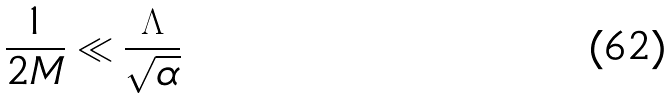<formula> <loc_0><loc_0><loc_500><loc_500>\frac { 1 } { 2 M } \ll \frac { \Lambda } { \sqrt { \alpha } }</formula> 